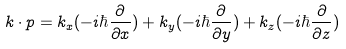<formula> <loc_0><loc_0><loc_500><loc_500>k \cdot p = k _ { x } ( - i \hbar { \frac { \partial } { \partial x } } ) + k _ { y } ( - i \hbar { \frac { \partial } { \partial y } } ) + k _ { z } ( - i \hbar { \frac { \partial } { \partial z } } )</formula> 